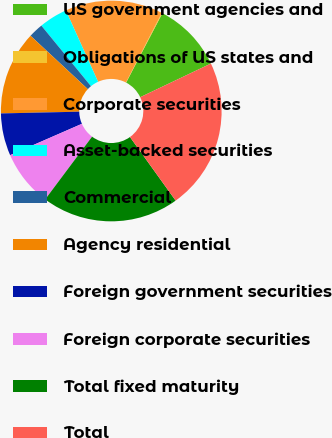Convert chart to OTSL. <chart><loc_0><loc_0><loc_500><loc_500><pie_chart><fcel>US government agencies and<fcel>Obligations of US states and<fcel>Corporate securities<fcel>Asset-backed securities<fcel>Commercial<fcel>Agency residential<fcel>Foreign government securities<fcel>Foreign corporate securities<fcel>Total fixed maturity<fcel>Total<nl><fcel>10.26%<fcel>0.1%<fcel>14.32%<fcel>4.17%<fcel>2.14%<fcel>12.29%<fcel>6.2%<fcel>8.23%<fcel>20.13%<fcel>22.16%<nl></chart> 